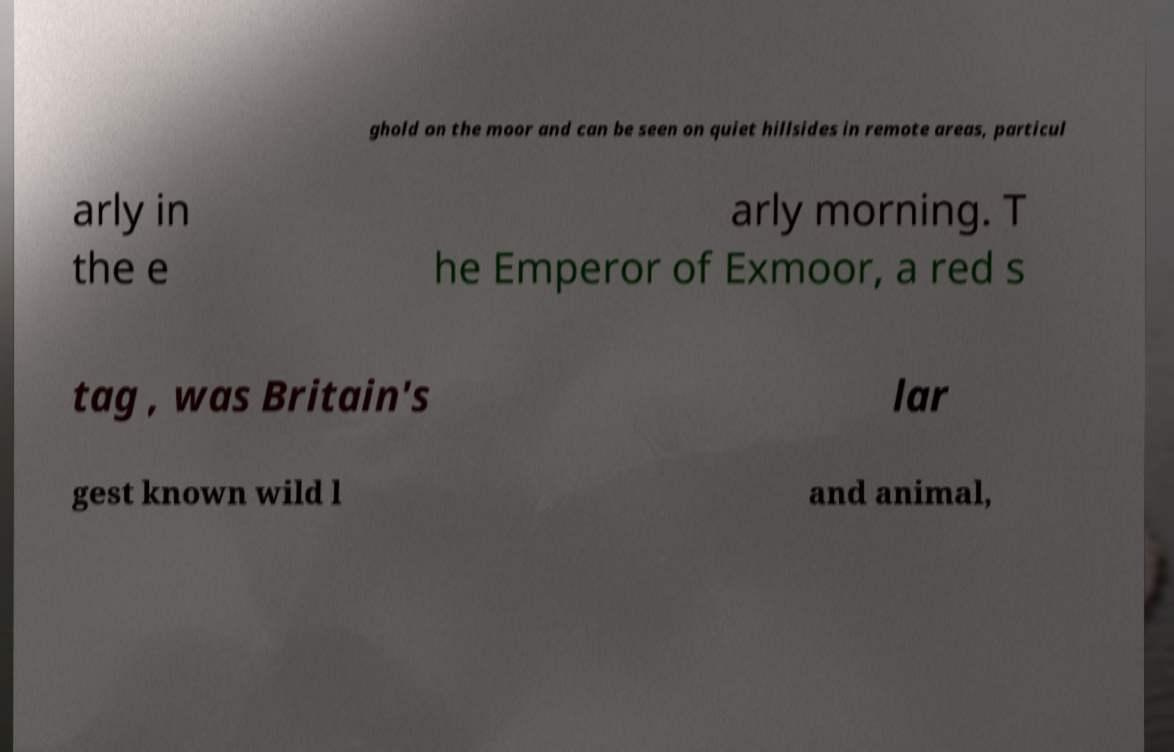Please read and relay the text visible in this image. What does it say? ghold on the moor and can be seen on quiet hillsides in remote areas, particul arly in the e arly morning. T he Emperor of Exmoor, a red s tag , was Britain's lar gest known wild l and animal, 